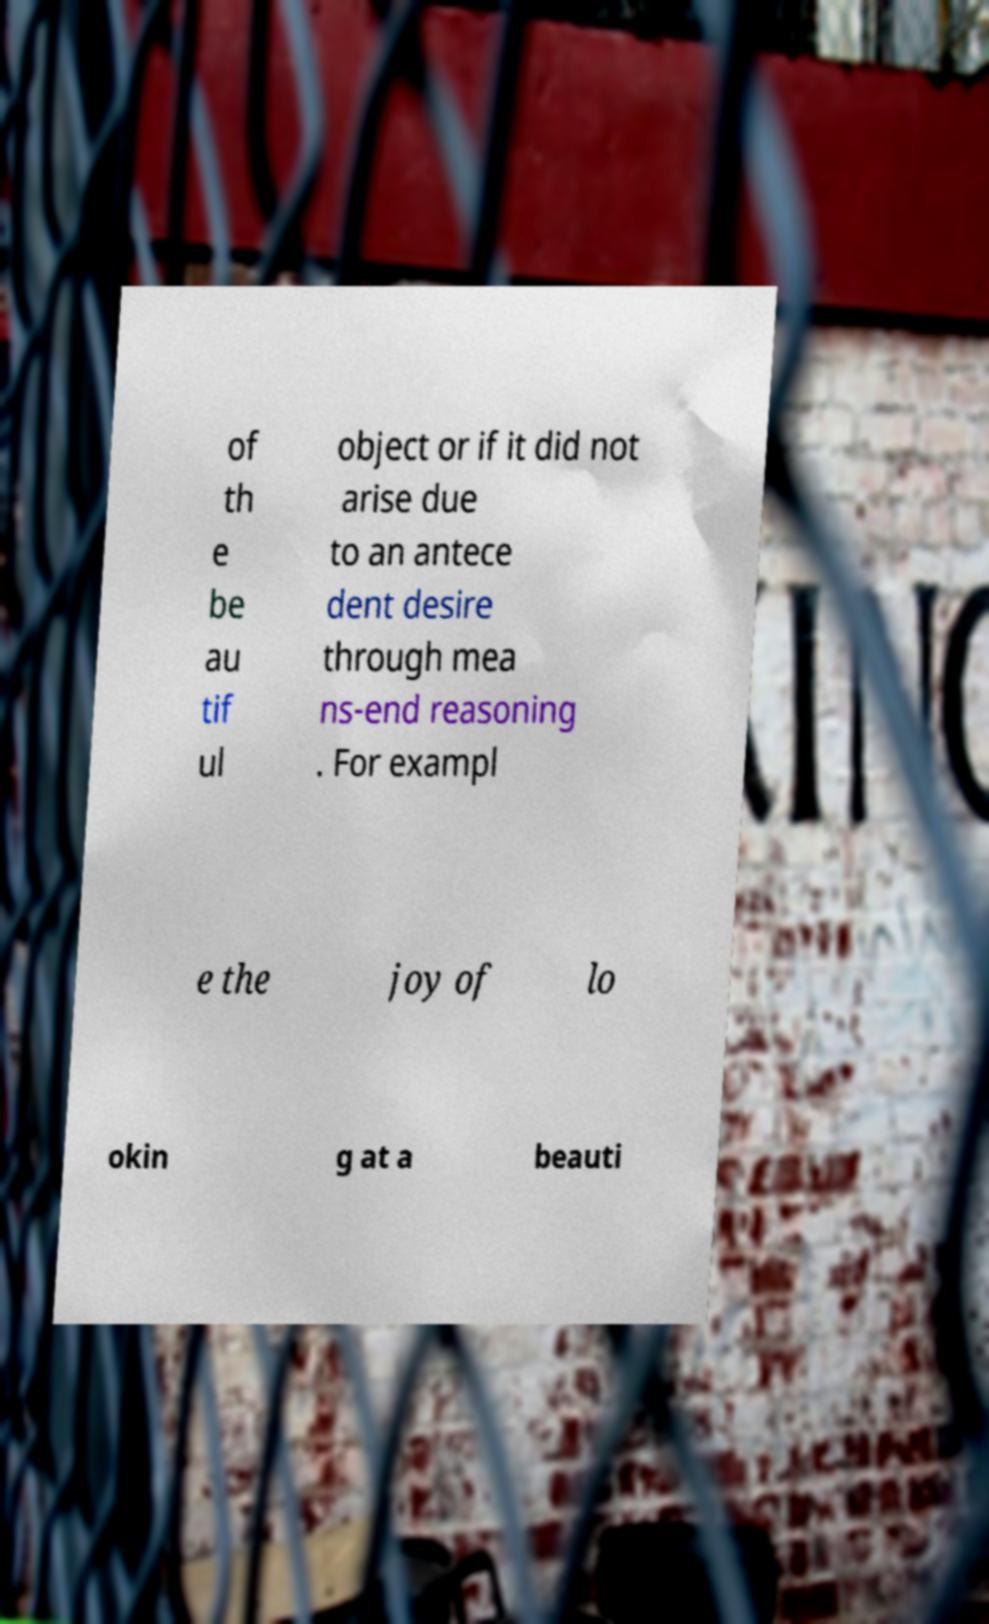I need the written content from this picture converted into text. Can you do that? of th e be au tif ul object or if it did not arise due to an antece dent desire through mea ns-end reasoning . For exampl e the joy of lo okin g at a beauti 